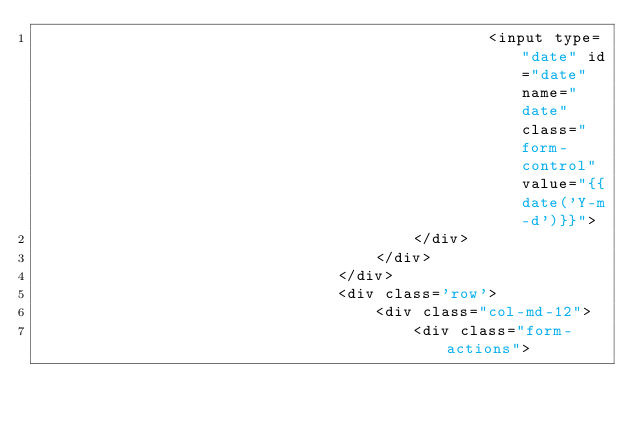<code> <loc_0><loc_0><loc_500><loc_500><_PHP_>                                                <input type="date" id="date" name="date" class="form-control" value="{{date('Y-m-d')}}">
                                        </div>
                                    </div>
                                </div>
                                <div class='row'>
                                    <div class="col-md-12">
                                        <div class="form-actions"></code> 